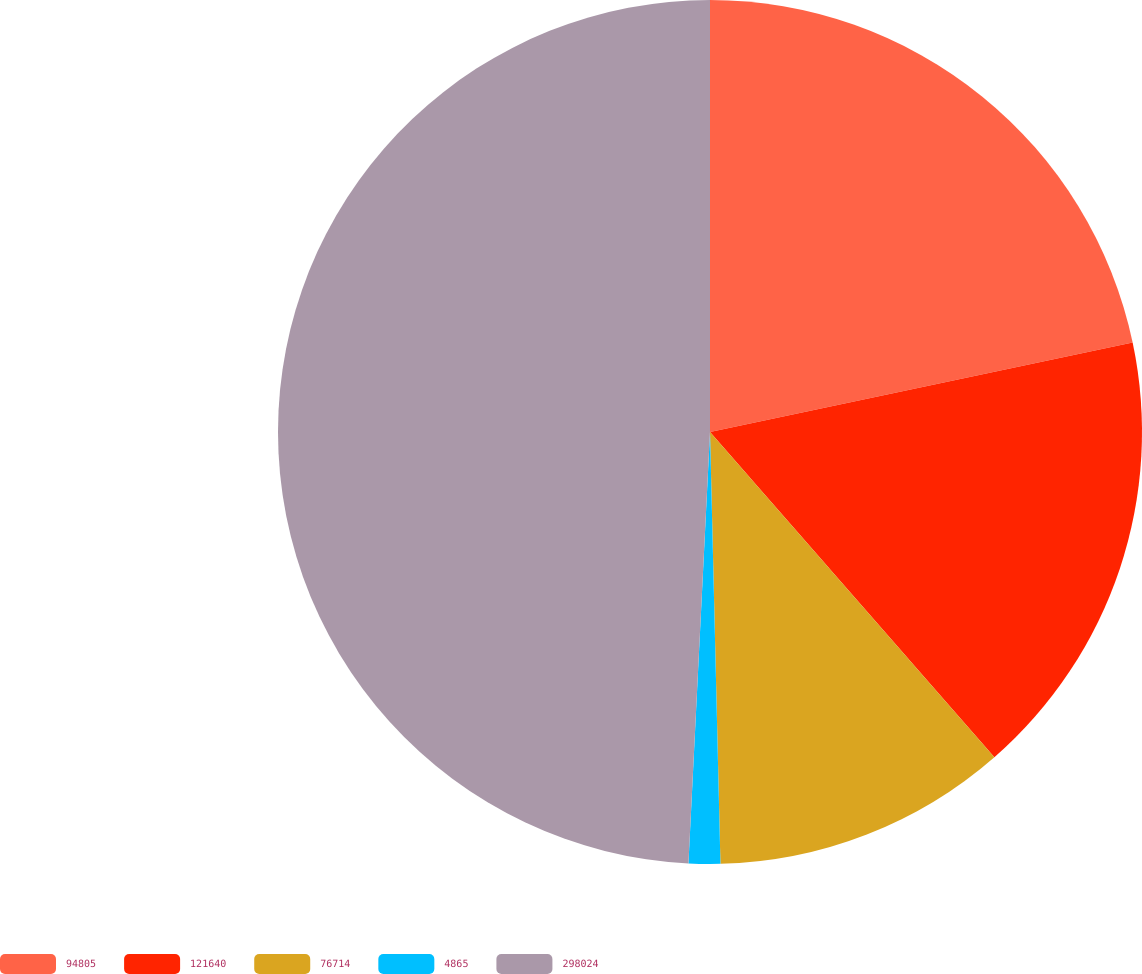<chart> <loc_0><loc_0><loc_500><loc_500><pie_chart><fcel>94805<fcel>121640<fcel>76714<fcel>4865<fcel>298024<nl><fcel>21.68%<fcel>16.88%<fcel>11.05%<fcel>1.18%<fcel>49.2%<nl></chart> 